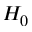Convert formula to latex. <formula><loc_0><loc_0><loc_500><loc_500>H _ { 0 }</formula> 